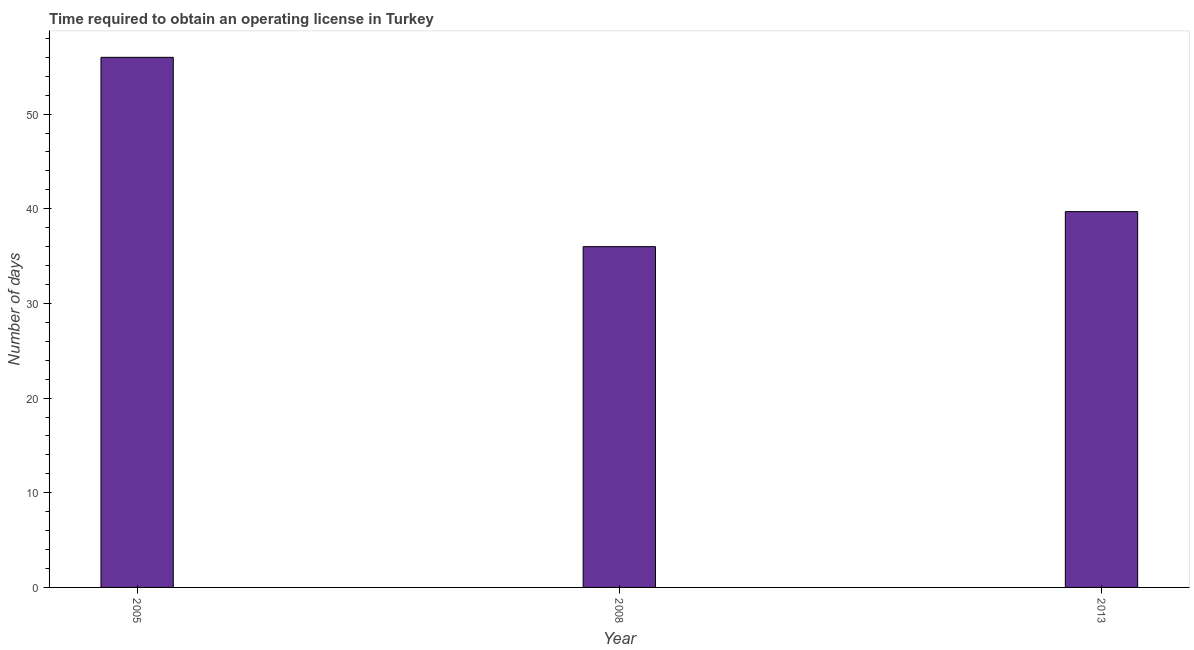Does the graph contain grids?
Your response must be concise. No. What is the title of the graph?
Provide a succinct answer. Time required to obtain an operating license in Turkey. What is the label or title of the Y-axis?
Ensure brevity in your answer.  Number of days. Across all years, what is the maximum number of days to obtain operating license?
Provide a succinct answer. 56. Across all years, what is the minimum number of days to obtain operating license?
Offer a terse response. 36. In which year was the number of days to obtain operating license minimum?
Your answer should be compact. 2008. What is the sum of the number of days to obtain operating license?
Provide a short and direct response. 131.7. What is the average number of days to obtain operating license per year?
Provide a succinct answer. 43.9. What is the median number of days to obtain operating license?
Offer a terse response. 39.7. What is the ratio of the number of days to obtain operating license in 2005 to that in 2008?
Provide a short and direct response. 1.56. What is the difference between the highest and the second highest number of days to obtain operating license?
Keep it short and to the point. 16.3. Is the sum of the number of days to obtain operating license in 2005 and 2013 greater than the maximum number of days to obtain operating license across all years?
Keep it short and to the point. Yes. In how many years, is the number of days to obtain operating license greater than the average number of days to obtain operating license taken over all years?
Ensure brevity in your answer.  1. How many years are there in the graph?
Your answer should be compact. 3. What is the Number of days in 2013?
Your response must be concise. 39.7. What is the difference between the Number of days in 2005 and 2008?
Your response must be concise. 20. What is the difference between the Number of days in 2005 and 2013?
Offer a terse response. 16.3. What is the difference between the Number of days in 2008 and 2013?
Make the answer very short. -3.7. What is the ratio of the Number of days in 2005 to that in 2008?
Your answer should be compact. 1.56. What is the ratio of the Number of days in 2005 to that in 2013?
Provide a short and direct response. 1.41. What is the ratio of the Number of days in 2008 to that in 2013?
Ensure brevity in your answer.  0.91. 